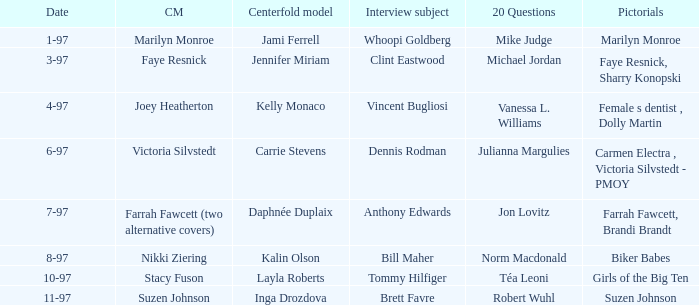What is the name of the cover model on 3-97? Faye Resnick. 